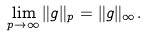<formula> <loc_0><loc_0><loc_500><loc_500>\lim _ { p \to \infty } \| g \| _ { p } = \| g \| _ { \infty } .</formula> 